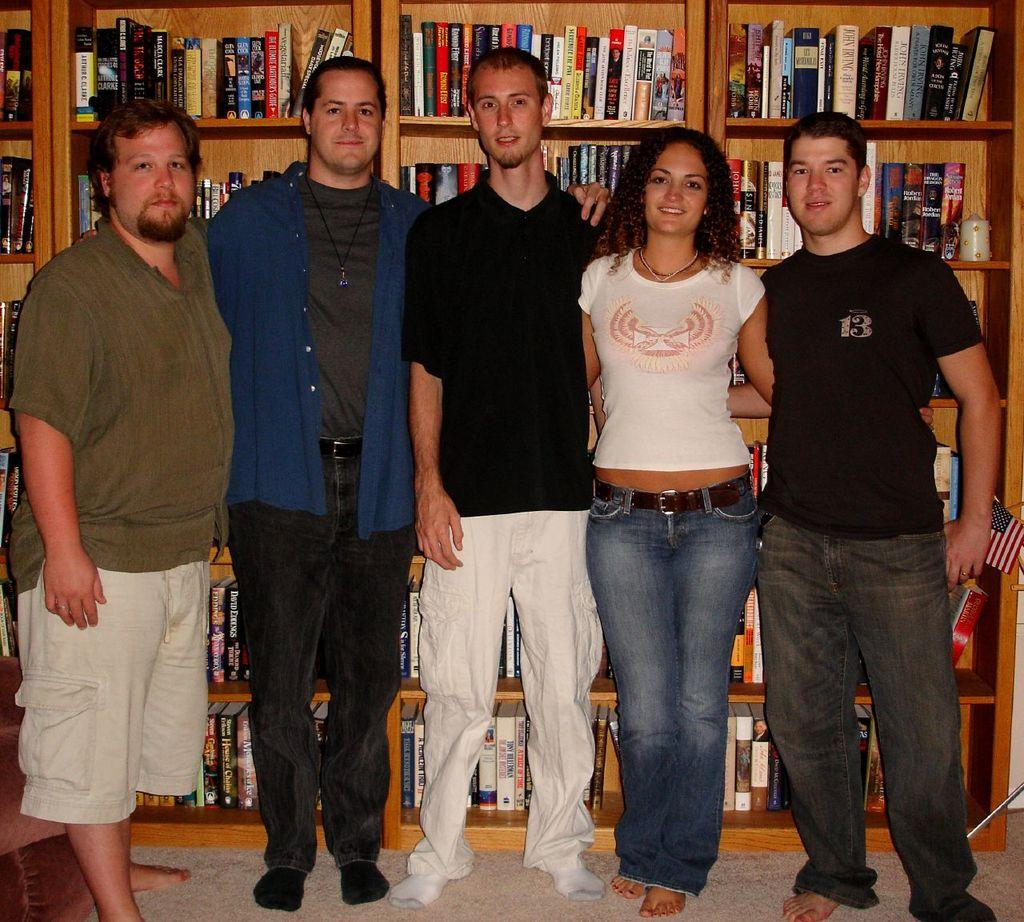How many people are present in the image? There are four men and one lady in the image, making a total of five people. What are the people in the image doing? The people are standing in the image. What can be seen in the background of the image? There are shelves in the background of the image. What is on the shelves? Books are arranged on the shelves. What type of fan can be seen in the image? There is no fan present in the image. 